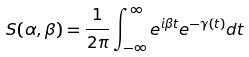<formula> <loc_0><loc_0><loc_500><loc_500>S ( \alpha , \beta ) = \frac { 1 } { 2 \pi } \int _ { - \infty } ^ { \infty } e ^ { i \beta t } e ^ { - \gamma ( t ) } d t</formula> 